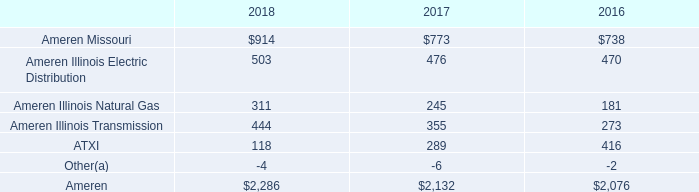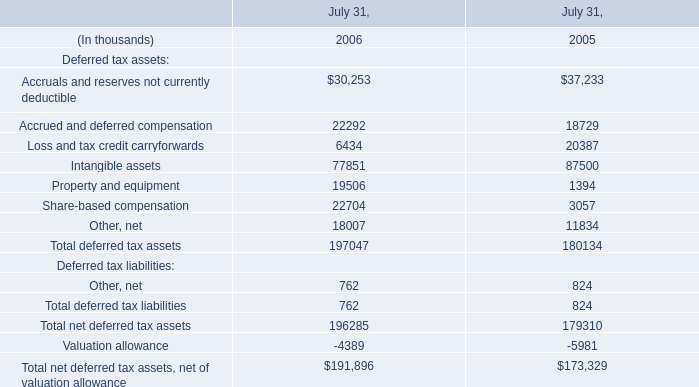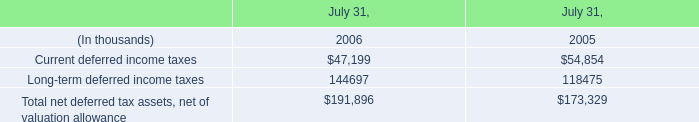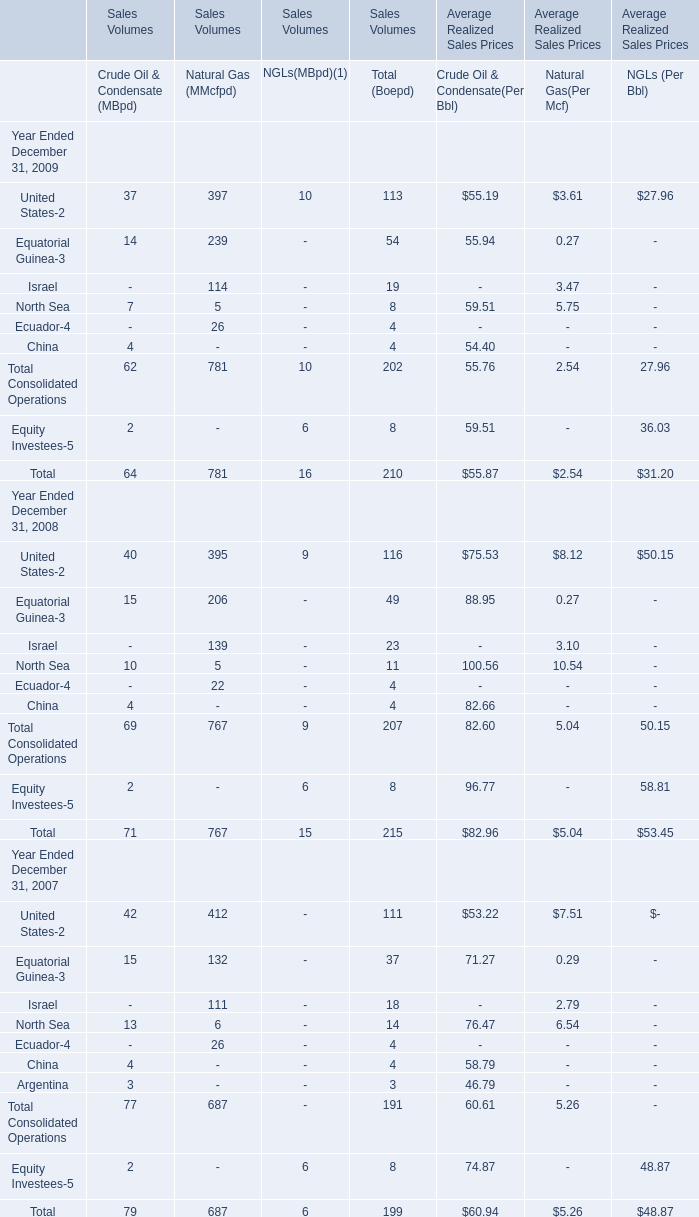What is the sum of NGLs(MBpd)(1) in the range of 0 and 100 in 2008? 
Computations: (9 + 6)
Answer: 15.0. 